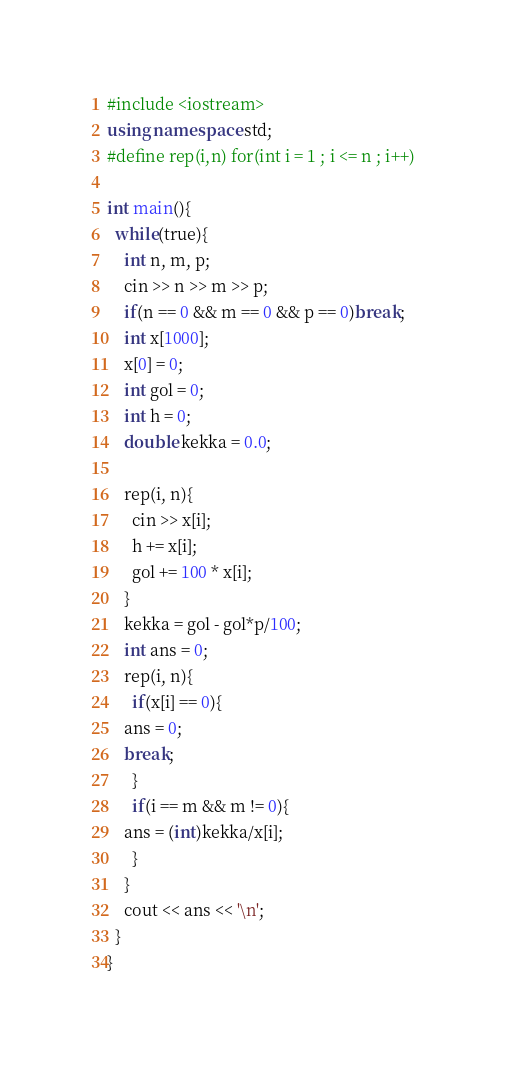<code> <loc_0><loc_0><loc_500><loc_500><_C++_>#include <iostream>
using namespace std;
#define rep(i,n) for(int i = 1 ; i <= n ; i++)

int main(){
  while(true){
    int n, m, p;
    cin >> n >> m >> p;
    if(n == 0 && m == 0 && p == 0)break;
    int x[1000];
    x[0] = 0;
    int gol = 0;
    int h = 0;
    double kekka = 0.0;
    
    rep(i, n){
      cin >> x[i];
      h += x[i];
      gol += 100 * x[i];
    }
    kekka = gol - gol*p/100;
    int ans = 0;
    rep(i, n){
      if(x[i] == 0){
	ans = 0;
	break;
      }
      if(i == m && m != 0){
	ans = (int)kekka/x[i];
      }
    }
    cout << ans << '\n';
  }
}</code> 